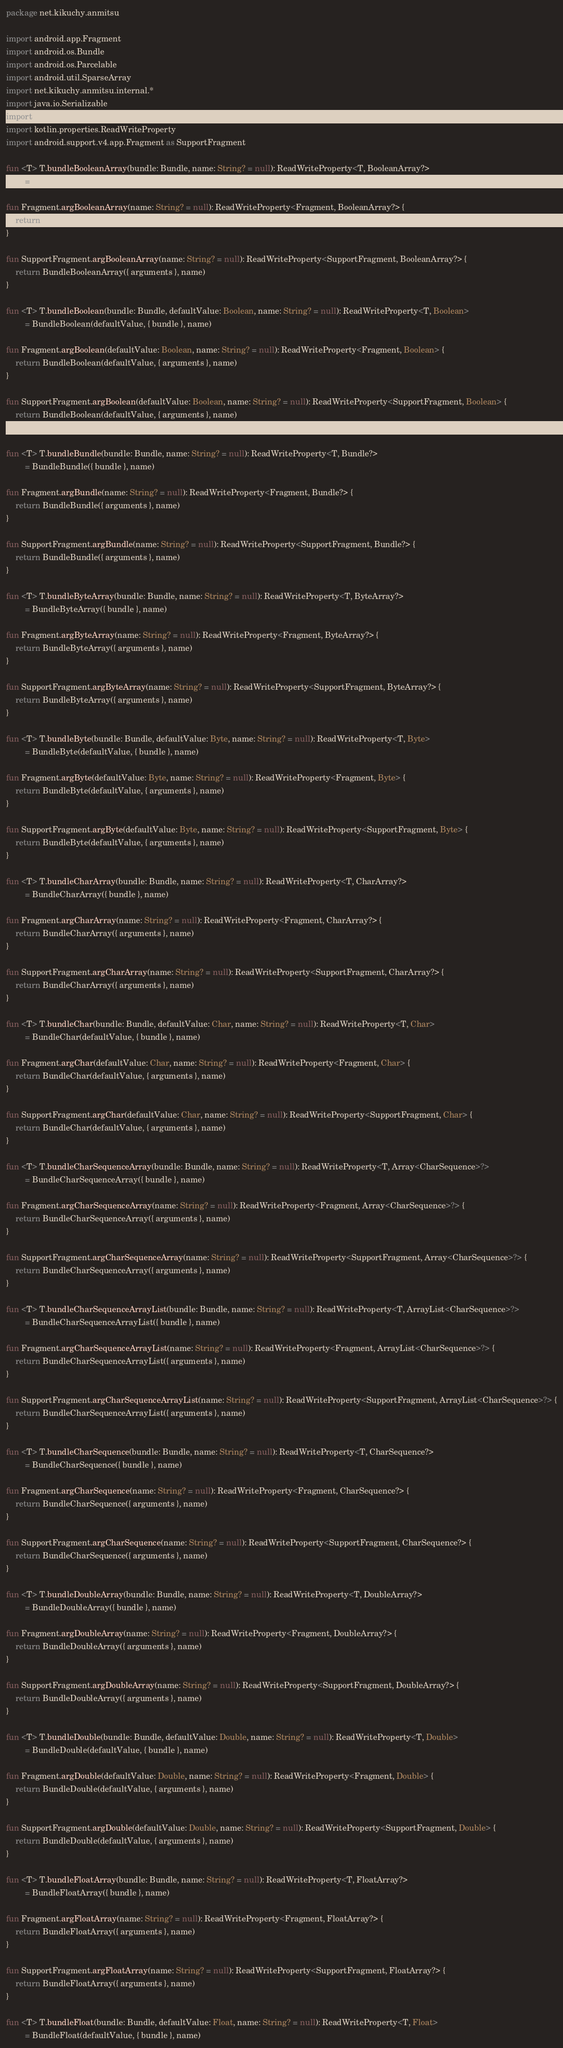<code> <loc_0><loc_0><loc_500><loc_500><_Kotlin_>package net.kikuchy.anmitsu

import android.app.Fragment
import android.os.Bundle
import android.os.Parcelable
import android.util.SparseArray
import net.kikuchy.anmitsu.internal.*
import java.io.Serializable
import java.util.*
import kotlin.properties.ReadWriteProperty
import android.support.v4.app.Fragment as SupportFragment

fun <T> T.bundleBooleanArray(bundle: Bundle, name: String? = null): ReadWriteProperty<T, BooleanArray?>
        = BundleBooleanArray({ bundle }, name)

fun Fragment.argBooleanArray(name: String? = null): ReadWriteProperty<Fragment, BooleanArray?> {
    return BundleBooleanArray({ arguments }, name)
}

fun SupportFragment.argBooleanArray(name: String? = null): ReadWriteProperty<SupportFragment, BooleanArray?> {
    return BundleBooleanArray({ arguments }, name)
}

fun <T> T.bundleBoolean(bundle: Bundle, defaultValue: Boolean, name: String? = null): ReadWriteProperty<T, Boolean>
        = BundleBoolean(defaultValue, { bundle }, name)

fun Fragment.argBoolean(defaultValue: Boolean, name: String? = null): ReadWriteProperty<Fragment, Boolean> {
    return BundleBoolean(defaultValue, { arguments }, name)
}

fun SupportFragment.argBoolean(defaultValue: Boolean, name: String? = null): ReadWriteProperty<SupportFragment, Boolean> {
    return BundleBoolean(defaultValue, { arguments }, name)
}

fun <T> T.bundleBundle(bundle: Bundle, name: String? = null): ReadWriteProperty<T, Bundle?>
        = BundleBundle({ bundle }, name)

fun Fragment.argBundle(name: String? = null): ReadWriteProperty<Fragment, Bundle?> {
    return BundleBundle({ arguments }, name)
}

fun SupportFragment.argBundle(name: String? = null): ReadWriteProperty<SupportFragment, Bundle?> {
    return BundleBundle({ arguments }, name)
}

fun <T> T.bundleByteArray(bundle: Bundle, name: String? = null): ReadWriteProperty<T, ByteArray?>
        = BundleByteArray({ bundle }, name)

fun Fragment.argByteArray(name: String? = null): ReadWriteProperty<Fragment, ByteArray?> {
    return BundleByteArray({ arguments }, name)
}

fun SupportFragment.argByteArray(name: String? = null): ReadWriteProperty<SupportFragment, ByteArray?> {
    return BundleByteArray({ arguments }, name)
}

fun <T> T.bundleByte(bundle: Bundle, defaultValue: Byte, name: String? = null): ReadWriteProperty<T, Byte>
        = BundleByte(defaultValue, { bundle }, name)

fun Fragment.argByte(defaultValue: Byte, name: String? = null): ReadWriteProperty<Fragment, Byte> {
    return BundleByte(defaultValue, { arguments }, name)
}

fun SupportFragment.argByte(defaultValue: Byte, name: String? = null): ReadWriteProperty<SupportFragment, Byte> {
    return BundleByte(defaultValue, { arguments }, name)
}

fun <T> T.bundleCharArray(bundle: Bundle, name: String? = null): ReadWriteProperty<T, CharArray?>
        = BundleCharArray({ bundle }, name)

fun Fragment.argCharArray(name: String? = null): ReadWriteProperty<Fragment, CharArray?> {
    return BundleCharArray({ arguments }, name)
}

fun SupportFragment.argCharArray(name: String? = null): ReadWriteProperty<SupportFragment, CharArray?> {
    return BundleCharArray({ arguments }, name)
}

fun <T> T.bundleChar(bundle: Bundle, defaultValue: Char, name: String? = null): ReadWriteProperty<T, Char>
        = BundleChar(defaultValue, { bundle }, name)

fun Fragment.argChar(defaultValue: Char, name: String? = null): ReadWriteProperty<Fragment, Char> {
    return BundleChar(defaultValue, { arguments }, name)
}

fun SupportFragment.argChar(defaultValue: Char, name: String? = null): ReadWriteProperty<SupportFragment, Char> {
    return BundleChar(defaultValue, { arguments }, name)
}

fun <T> T.bundleCharSequenceArray(bundle: Bundle, name: String? = null): ReadWriteProperty<T, Array<CharSequence>?>
        = BundleCharSequenceArray({ bundle }, name)

fun Fragment.argCharSequenceArray(name: String? = null): ReadWriteProperty<Fragment, Array<CharSequence>?> {
    return BundleCharSequenceArray({ arguments }, name)
}

fun SupportFragment.argCharSequenceArray(name: String? = null): ReadWriteProperty<SupportFragment, Array<CharSequence>?> {
    return BundleCharSequenceArray({ arguments }, name)
}

fun <T> T.bundleCharSequenceArrayList(bundle: Bundle, name: String? = null): ReadWriteProperty<T, ArrayList<CharSequence>?>
        = BundleCharSequenceArrayList({ bundle }, name)

fun Fragment.argCharSequenceArrayList(name: String? = null): ReadWriteProperty<Fragment, ArrayList<CharSequence>?> {
    return BundleCharSequenceArrayList({ arguments }, name)
}

fun SupportFragment.argCharSequenceArrayList(name: String? = null): ReadWriteProperty<SupportFragment, ArrayList<CharSequence>?> {
    return BundleCharSequenceArrayList({ arguments }, name)
}

fun <T> T.bundleCharSequence(bundle: Bundle, name: String? = null): ReadWriteProperty<T, CharSequence?>
        = BundleCharSequence({ bundle }, name)

fun Fragment.argCharSequence(name: String? = null): ReadWriteProperty<Fragment, CharSequence?> {
    return BundleCharSequence({ arguments }, name)
}

fun SupportFragment.argCharSequence(name: String? = null): ReadWriteProperty<SupportFragment, CharSequence?> {
    return BundleCharSequence({ arguments }, name)
}

fun <T> T.bundleDoubleArray(bundle: Bundle, name: String? = null): ReadWriteProperty<T, DoubleArray?>
        = BundleDoubleArray({ bundle }, name)

fun Fragment.argDoubleArray(name: String? = null): ReadWriteProperty<Fragment, DoubleArray?> {
    return BundleDoubleArray({ arguments }, name)
}

fun SupportFragment.argDoubleArray(name: String? = null): ReadWriteProperty<SupportFragment, DoubleArray?> {
    return BundleDoubleArray({ arguments }, name)
}

fun <T> T.bundleDouble(bundle: Bundle, defaultValue: Double, name: String? = null): ReadWriteProperty<T, Double>
        = BundleDouble(defaultValue, { bundle }, name)

fun Fragment.argDouble(defaultValue: Double, name: String? = null): ReadWriteProperty<Fragment, Double> {
    return BundleDouble(defaultValue, { arguments }, name)
}

fun SupportFragment.argDouble(defaultValue: Double, name: String? = null): ReadWriteProperty<SupportFragment, Double> {
    return BundleDouble(defaultValue, { arguments }, name)
}

fun <T> T.bundleFloatArray(bundle: Bundle, name: String? = null): ReadWriteProperty<T, FloatArray?>
        = BundleFloatArray({ bundle }, name)

fun Fragment.argFloatArray(name: String? = null): ReadWriteProperty<Fragment, FloatArray?> {
    return BundleFloatArray({ arguments }, name)
}

fun SupportFragment.argFloatArray(name: String? = null): ReadWriteProperty<SupportFragment, FloatArray?> {
    return BundleFloatArray({ arguments }, name)
}

fun <T> T.bundleFloat(bundle: Bundle, defaultValue: Float, name: String? = null): ReadWriteProperty<T, Float>
        = BundleFloat(defaultValue, { bundle }, name)
</code> 